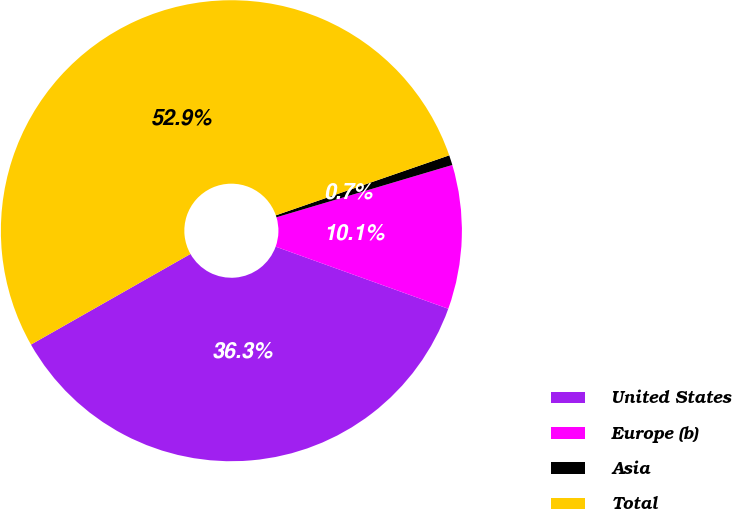Convert chart. <chart><loc_0><loc_0><loc_500><loc_500><pie_chart><fcel>United States<fcel>Europe (b)<fcel>Asia<fcel>Total<nl><fcel>36.28%<fcel>10.1%<fcel>0.7%<fcel>52.92%<nl></chart> 